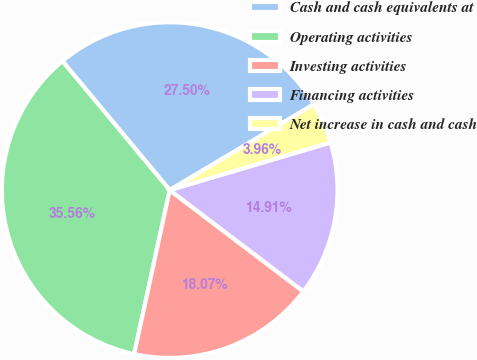<chart> <loc_0><loc_0><loc_500><loc_500><pie_chart><fcel>Cash and cash equivalents at<fcel>Operating activities<fcel>Investing activities<fcel>Financing activities<fcel>Net increase in cash and cash<nl><fcel>27.5%<fcel>35.56%<fcel>18.07%<fcel>14.91%<fcel>3.96%<nl></chart> 